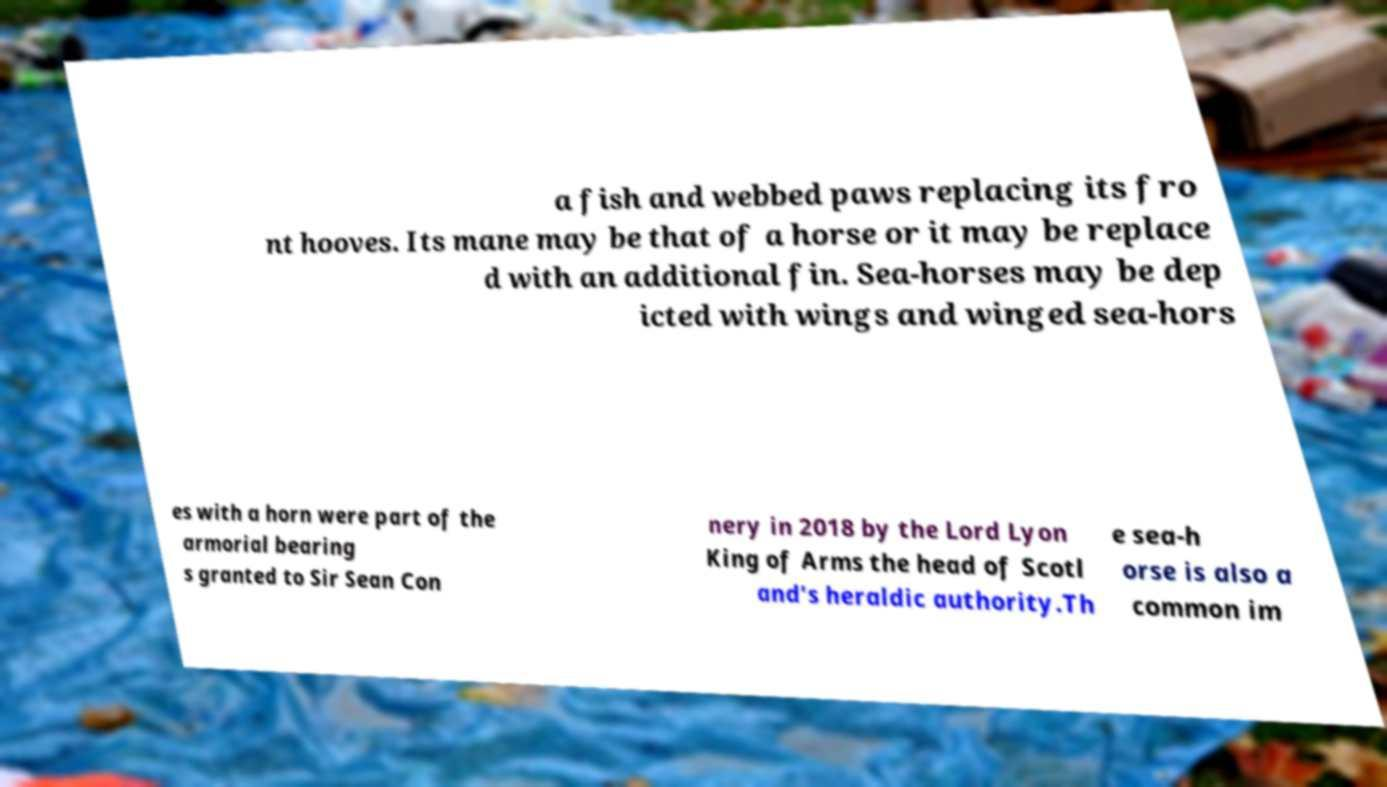Please identify and transcribe the text found in this image. a fish and webbed paws replacing its fro nt hooves. Its mane may be that of a horse or it may be replace d with an additional fin. Sea-horses may be dep icted with wings and winged sea-hors es with a horn were part of the armorial bearing s granted to Sir Sean Con nery in 2018 by the Lord Lyon King of Arms the head of Scotl and's heraldic authority.Th e sea-h orse is also a common im 